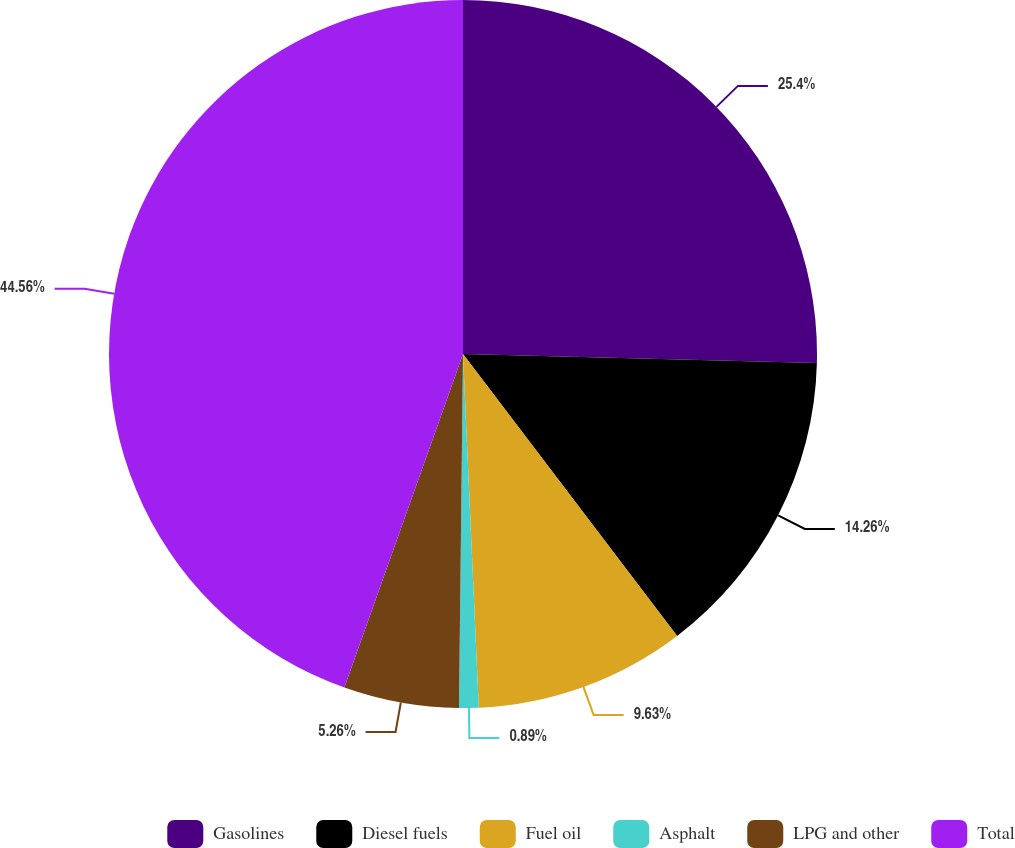<chart> <loc_0><loc_0><loc_500><loc_500><pie_chart><fcel>Gasolines<fcel>Diesel fuels<fcel>Fuel oil<fcel>Asphalt<fcel>LPG and other<fcel>Total<nl><fcel>25.4%<fcel>14.26%<fcel>9.63%<fcel>0.89%<fcel>5.26%<fcel>44.56%<nl></chart> 